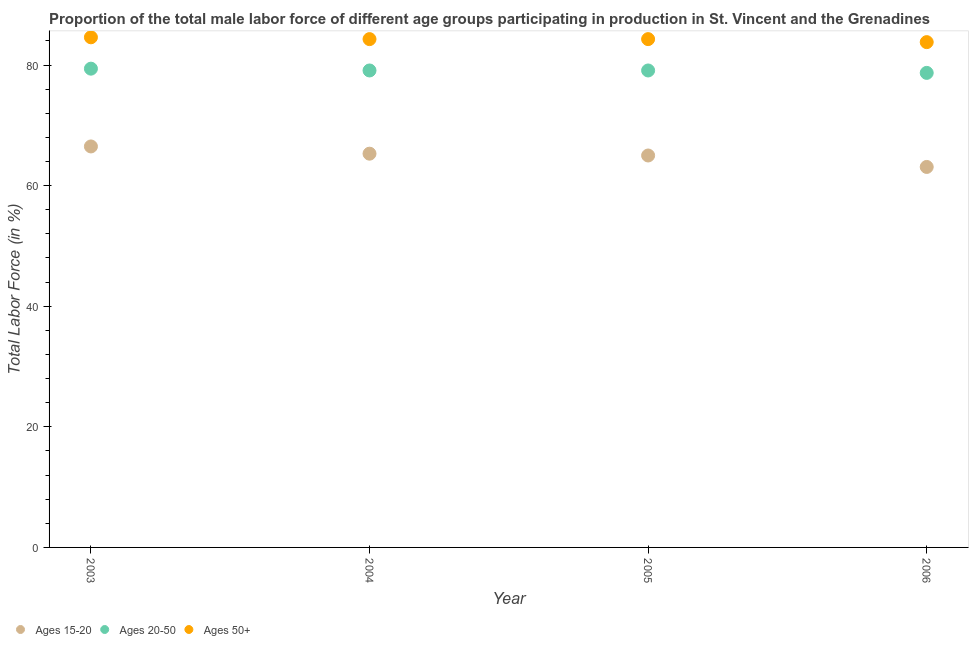What is the percentage of male labor force above age 50 in 2003?
Provide a short and direct response. 84.6. Across all years, what is the maximum percentage of male labor force within the age group 15-20?
Make the answer very short. 66.5. Across all years, what is the minimum percentage of male labor force above age 50?
Provide a succinct answer. 83.8. In which year was the percentage of male labor force above age 50 minimum?
Make the answer very short. 2006. What is the total percentage of male labor force within the age group 15-20 in the graph?
Offer a very short reply. 259.9. What is the difference between the percentage of male labor force within the age group 20-50 in 2005 and that in 2006?
Your answer should be very brief. 0.4. What is the difference between the percentage of male labor force above age 50 in 2006 and the percentage of male labor force within the age group 15-20 in 2005?
Give a very brief answer. 18.8. What is the average percentage of male labor force above age 50 per year?
Offer a very short reply. 84.25. In the year 2003, what is the difference between the percentage of male labor force above age 50 and percentage of male labor force within the age group 15-20?
Your answer should be very brief. 18.1. In how many years, is the percentage of male labor force within the age group 20-50 greater than 44 %?
Ensure brevity in your answer.  4. What is the ratio of the percentage of male labor force within the age group 15-20 in 2003 to that in 2006?
Your answer should be compact. 1.05. Is the difference between the percentage of male labor force above age 50 in 2005 and 2006 greater than the difference between the percentage of male labor force within the age group 20-50 in 2005 and 2006?
Your answer should be compact. Yes. What is the difference between the highest and the second highest percentage of male labor force within the age group 20-50?
Your answer should be very brief. 0.3. What is the difference between the highest and the lowest percentage of male labor force within the age group 20-50?
Provide a short and direct response. 0.7. In how many years, is the percentage of male labor force above age 50 greater than the average percentage of male labor force above age 50 taken over all years?
Provide a succinct answer. 3. Is the sum of the percentage of male labor force within the age group 20-50 in 2005 and 2006 greater than the maximum percentage of male labor force above age 50 across all years?
Your answer should be very brief. Yes. Does the percentage of male labor force above age 50 monotonically increase over the years?
Give a very brief answer. No. How many years are there in the graph?
Provide a short and direct response. 4. How are the legend labels stacked?
Make the answer very short. Horizontal. What is the title of the graph?
Offer a very short reply. Proportion of the total male labor force of different age groups participating in production in St. Vincent and the Grenadines. Does "Infant(female)" appear as one of the legend labels in the graph?
Offer a terse response. No. What is the Total Labor Force (in %) in Ages 15-20 in 2003?
Offer a terse response. 66.5. What is the Total Labor Force (in %) in Ages 20-50 in 2003?
Provide a succinct answer. 79.4. What is the Total Labor Force (in %) of Ages 50+ in 2003?
Keep it short and to the point. 84.6. What is the Total Labor Force (in %) of Ages 15-20 in 2004?
Your response must be concise. 65.3. What is the Total Labor Force (in %) of Ages 20-50 in 2004?
Your answer should be very brief. 79.1. What is the Total Labor Force (in %) of Ages 50+ in 2004?
Your answer should be very brief. 84.3. What is the Total Labor Force (in %) in Ages 20-50 in 2005?
Provide a succinct answer. 79.1. What is the Total Labor Force (in %) in Ages 50+ in 2005?
Your answer should be very brief. 84.3. What is the Total Labor Force (in %) in Ages 15-20 in 2006?
Keep it short and to the point. 63.1. What is the Total Labor Force (in %) of Ages 20-50 in 2006?
Offer a terse response. 78.7. What is the Total Labor Force (in %) of Ages 50+ in 2006?
Your answer should be compact. 83.8. Across all years, what is the maximum Total Labor Force (in %) of Ages 15-20?
Offer a terse response. 66.5. Across all years, what is the maximum Total Labor Force (in %) in Ages 20-50?
Provide a succinct answer. 79.4. Across all years, what is the maximum Total Labor Force (in %) in Ages 50+?
Provide a succinct answer. 84.6. Across all years, what is the minimum Total Labor Force (in %) in Ages 15-20?
Your response must be concise. 63.1. Across all years, what is the minimum Total Labor Force (in %) in Ages 20-50?
Your response must be concise. 78.7. Across all years, what is the minimum Total Labor Force (in %) in Ages 50+?
Ensure brevity in your answer.  83.8. What is the total Total Labor Force (in %) of Ages 15-20 in the graph?
Offer a terse response. 259.9. What is the total Total Labor Force (in %) of Ages 20-50 in the graph?
Offer a terse response. 316.3. What is the total Total Labor Force (in %) of Ages 50+ in the graph?
Your response must be concise. 337. What is the difference between the Total Labor Force (in %) in Ages 15-20 in 2003 and that in 2004?
Your answer should be very brief. 1.2. What is the difference between the Total Labor Force (in %) in Ages 15-20 in 2003 and that in 2005?
Provide a succinct answer. 1.5. What is the difference between the Total Labor Force (in %) of Ages 20-50 in 2003 and that in 2005?
Provide a succinct answer. 0.3. What is the difference between the Total Labor Force (in %) in Ages 50+ in 2003 and that in 2005?
Make the answer very short. 0.3. What is the difference between the Total Labor Force (in %) of Ages 50+ in 2004 and that in 2005?
Ensure brevity in your answer.  0. What is the difference between the Total Labor Force (in %) in Ages 15-20 in 2004 and that in 2006?
Your response must be concise. 2.2. What is the difference between the Total Labor Force (in %) in Ages 20-50 in 2004 and that in 2006?
Ensure brevity in your answer.  0.4. What is the difference between the Total Labor Force (in %) in Ages 50+ in 2004 and that in 2006?
Offer a very short reply. 0.5. What is the difference between the Total Labor Force (in %) of Ages 20-50 in 2005 and that in 2006?
Keep it short and to the point. 0.4. What is the difference between the Total Labor Force (in %) in Ages 15-20 in 2003 and the Total Labor Force (in %) in Ages 20-50 in 2004?
Offer a very short reply. -12.6. What is the difference between the Total Labor Force (in %) of Ages 15-20 in 2003 and the Total Labor Force (in %) of Ages 50+ in 2004?
Your response must be concise. -17.8. What is the difference between the Total Labor Force (in %) in Ages 15-20 in 2003 and the Total Labor Force (in %) in Ages 50+ in 2005?
Your answer should be compact. -17.8. What is the difference between the Total Labor Force (in %) in Ages 15-20 in 2003 and the Total Labor Force (in %) in Ages 50+ in 2006?
Ensure brevity in your answer.  -17.3. What is the difference between the Total Labor Force (in %) of Ages 15-20 in 2004 and the Total Labor Force (in %) of Ages 50+ in 2005?
Your answer should be very brief. -19. What is the difference between the Total Labor Force (in %) of Ages 20-50 in 2004 and the Total Labor Force (in %) of Ages 50+ in 2005?
Your answer should be compact. -5.2. What is the difference between the Total Labor Force (in %) of Ages 15-20 in 2004 and the Total Labor Force (in %) of Ages 20-50 in 2006?
Keep it short and to the point. -13.4. What is the difference between the Total Labor Force (in %) of Ages 15-20 in 2004 and the Total Labor Force (in %) of Ages 50+ in 2006?
Offer a terse response. -18.5. What is the difference between the Total Labor Force (in %) in Ages 15-20 in 2005 and the Total Labor Force (in %) in Ages 20-50 in 2006?
Give a very brief answer. -13.7. What is the difference between the Total Labor Force (in %) of Ages 15-20 in 2005 and the Total Labor Force (in %) of Ages 50+ in 2006?
Make the answer very short. -18.8. What is the average Total Labor Force (in %) in Ages 15-20 per year?
Your answer should be very brief. 64.97. What is the average Total Labor Force (in %) of Ages 20-50 per year?
Provide a succinct answer. 79.08. What is the average Total Labor Force (in %) of Ages 50+ per year?
Offer a very short reply. 84.25. In the year 2003, what is the difference between the Total Labor Force (in %) of Ages 15-20 and Total Labor Force (in %) of Ages 20-50?
Your response must be concise. -12.9. In the year 2003, what is the difference between the Total Labor Force (in %) in Ages 15-20 and Total Labor Force (in %) in Ages 50+?
Ensure brevity in your answer.  -18.1. In the year 2004, what is the difference between the Total Labor Force (in %) in Ages 20-50 and Total Labor Force (in %) in Ages 50+?
Offer a terse response. -5.2. In the year 2005, what is the difference between the Total Labor Force (in %) of Ages 15-20 and Total Labor Force (in %) of Ages 20-50?
Ensure brevity in your answer.  -14.1. In the year 2005, what is the difference between the Total Labor Force (in %) in Ages 15-20 and Total Labor Force (in %) in Ages 50+?
Your answer should be compact. -19.3. In the year 2005, what is the difference between the Total Labor Force (in %) in Ages 20-50 and Total Labor Force (in %) in Ages 50+?
Provide a short and direct response. -5.2. In the year 2006, what is the difference between the Total Labor Force (in %) of Ages 15-20 and Total Labor Force (in %) of Ages 20-50?
Your answer should be very brief. -15.6. In the year 2006, what is the difference between the Total Labor Force (in %) in Ages 15-20 and Total Labor Force (in %) in Ages 50+?
Your response must be concise. -20.7. In the year 2006, what is the difference between the Total Labor Force (in %) in Ages 20-50 and Total Labor Force (in %) in Ages 50+?
Keep it short and to the point. -5.1. What is the ratio of the Total Labor Force (in %) of Ages 15-20 in 2003 to that in 2004?
Offer a terse response. 1.02. What is the ratio of the Total Labor Force (in %) of Ages 20-50 in 2003 to that in 2004?
Provide a short and direct response. 1. What is the ratio of the Total Labor Force (in %) in Ages 50+ in 2003 to that in 2004?
Your answer should be very brief. 1. What is the ratio of the Total Labor Force (in %) in Ages 15-20 in 2003 to that in 2005?
Your answer should be very brief. 1.02. What is the ratio of the Total Labor Force (in %) in Ages 50+ in 2003 to that in 2005?
Make the answer very short. 1. What is the ratio of the Total Labor Force (in %) in Ages 15-20 in 2003 to that in 2006?
Provide a short and direct response. 1.05. What is the ratio of the Total Labor Force (in %) of Ages 20-50 in 2003 to that in 2006?
Give a very brief answer. 1.01. What is the ratio of the Total Labor Force (in %) in Ages 50+ in 2003 to that in 2006?
Keep it short and to the point. 1.01. What is the ratio of the Total Labor Force (in %) in Ages 15-20 in 2004 to that in 2005?
Make the answer very short. 1. What is the ratio of the Total Labor Force (in %) of Ages 20-50 in 2004 to that in 2005?
Ensure brevity in your answer.  1. What is the ratio of the Total Labor Force (in %) of Ages 50+ in 2004 to that in 2005?
Your answer should be very brief. 1. What is the ratio of the Total Labor Force (in %) in Ages 15-20 in 2004 to that in 2006?
Keep it short and to the point. 1.03. What is the ratio of the Total Labor Force (in %) of Ages 15-20 in 2005 to that in 2006?
Offer a very short reply. 1.03. What is the ratio of the Total Labor Force (in %) in Ages 20-50 in 2005 to that in 2006?
Your response must be concise. 1.01. What is the difference between the highest and the second highest Total Labor Force (in %) of Ages 15-20?
Provide a succinct answer. 1.2. What is the difference between the highest and the second highest Total Labor Force (in %) of Ages 20-50?
Your answer should be compact. 0.3. What is the difference between the highest and the second highest Total Labor Force (in %) of Ages 50+?
Give a very brief answer. 0.3. What is the difference between the highest and the lowest Total Labor Force (in %) of Ages 15-20?
Give a very brief answer. 3.4. 